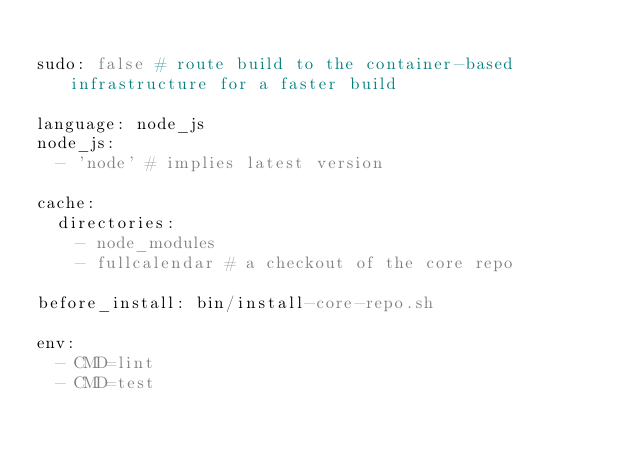Convert code to text. <code><loc_0><loc_0><loc_500><loc_500><_YAML_>
sudo: false # route build to the container-based infrastructure for a faster build

language: node_js
node_js:
  - 'node' # implies latest version

cache:
  directories:
    - node_modules
    - fullcalendar # a checkout of the core repo

before_install: bin/install-core-repo.sh

env:
  - CMD=lint
  - CMD=test</code> 